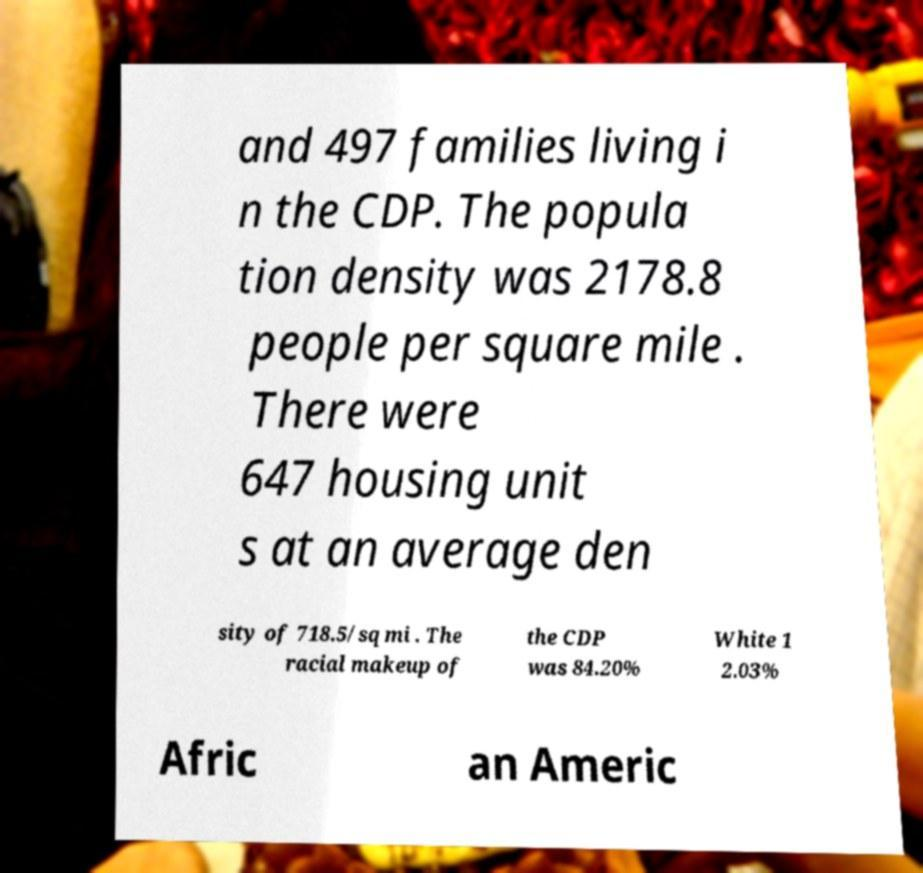For documentation purposes, I need the text within this image transcribed. Could you provide that? and 497 families living i n the CDP. The popula tion density was 2178.8 people per square mile . There were 647 housing unit s at an average den sity of 718.5/sq mi . The racial makeup of the CDP was 84.20% White 1 2.03% Afric an Americ 